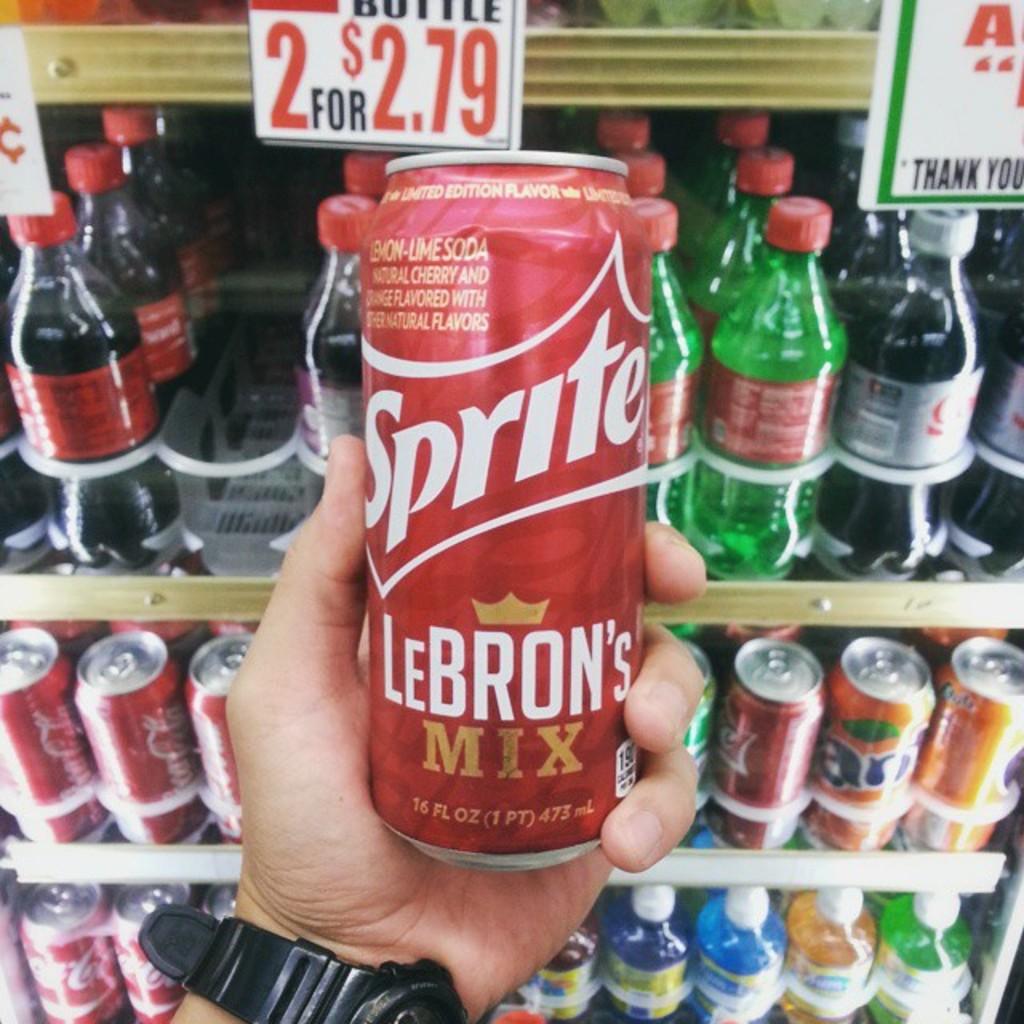What is the brand name on the can?
Make the answer very short. Sprite. What type of sprite is being featured?
Your answer should be very brief. Lebron's mix. 